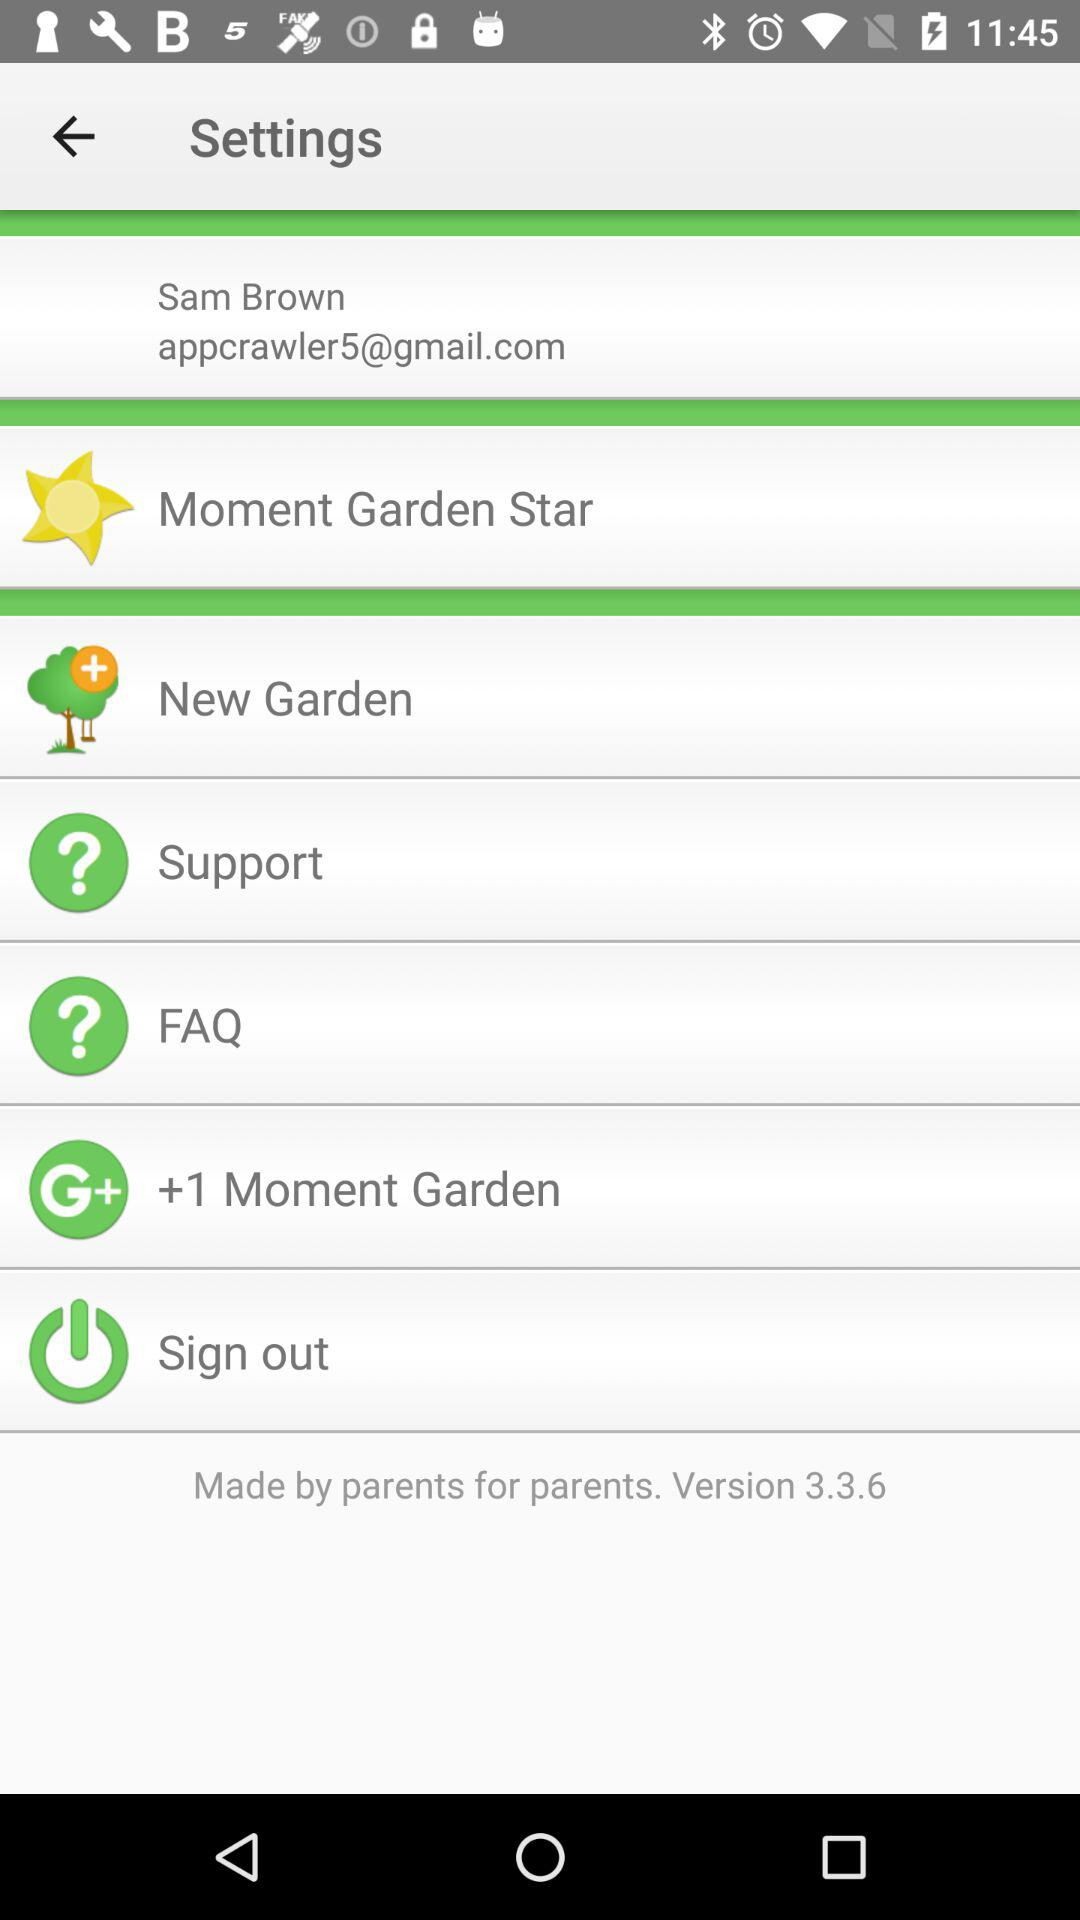What is the version of the app? The version of the app is 3.3.6. 